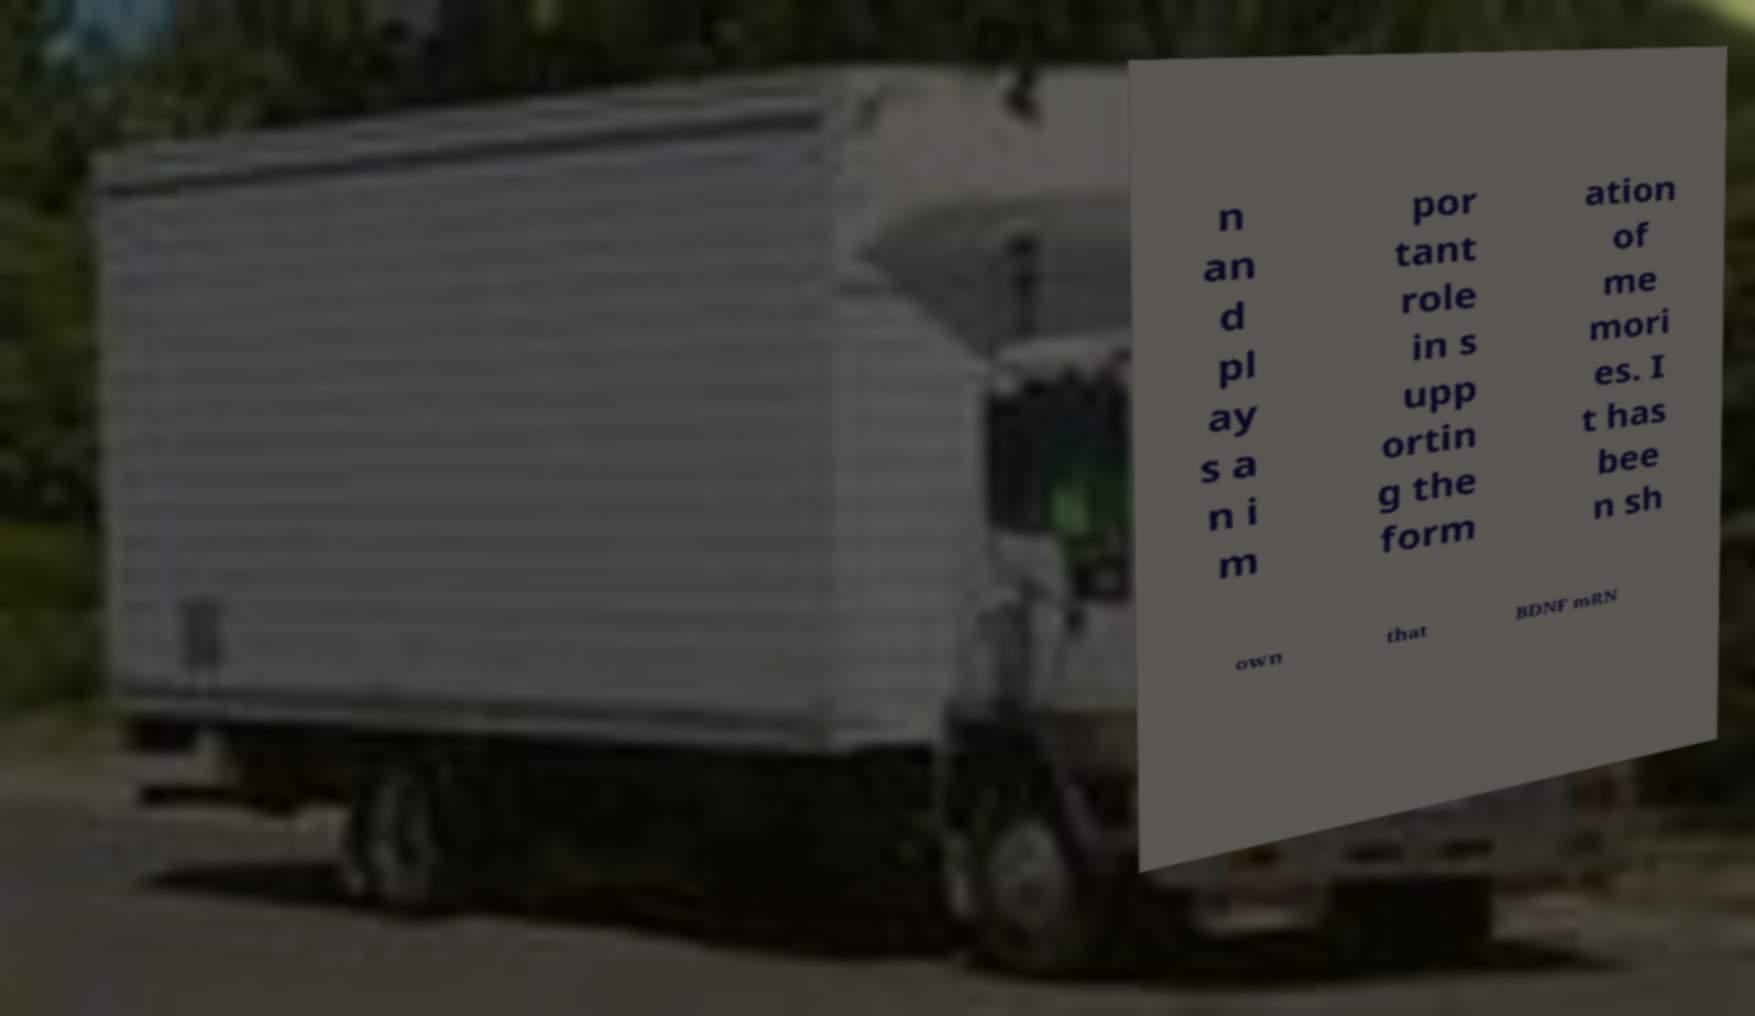Can you read and provide the text displayed in the image?This photo seems to have some interesting text. Can you extract and type it out for me? n an d pl ay s a n i m por tant role in s upp ortin g the form ation of me mori es. I t has bee n sh own that BDNF mRN 